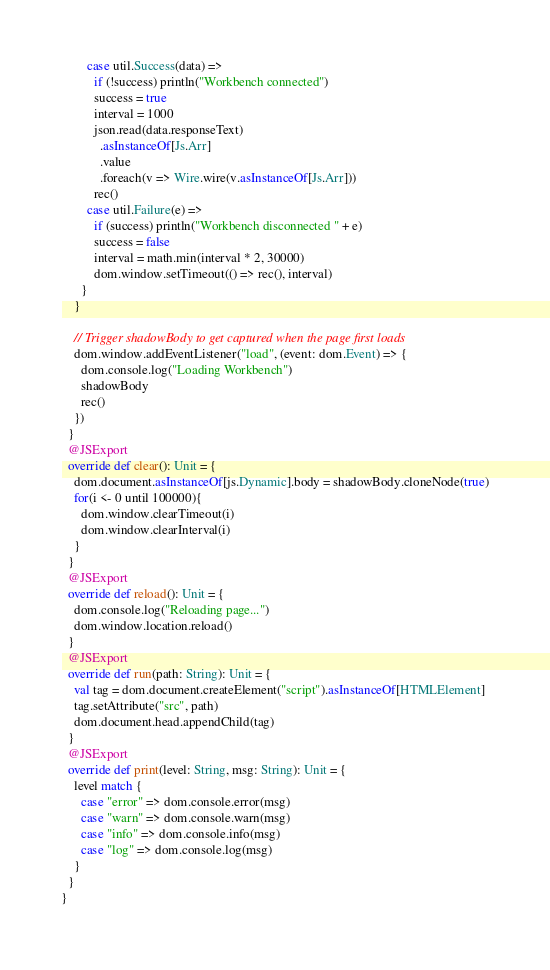<code> <loc_0><loc_0><loc_500><loc_500><_Scala_>        case util.Success(data) =>
          if (!success) println("Workbench connected")
          success = true
          interval = 1000
          json.read(data.responseText)
            .asInstanceOf[Js.Arr]
            .value
            .foreach(v => Wire.wire(v.asInstanceOf[Js.Arr]))
          rec()
        case util.Failure(e) =>
          if (success) println("Workbench disconnected " + e)
          success = false
          interval = math.min(interval * 2, 30000)
          dom.window.setTimeout(() => rec(), interval)
      }
    }

    // Trigger shadowBody to get captured when the page first loads
    dom.window.addEventListener("load", (event: dom.Event) => {
      dom.console.log("Loading Workbench")
      shadowBody
      rec()
    })
  }
  @JSExport
  override def clear(): Unit = {
    dom.document.asInstanceOf[js.Dynamic].body = shadowBody.cloneNode(true)
    for(i <- 0 until 100000){
      dom.window.clearTimeout(i)
      dom.window.clearInterval(i)
    }
  }
  @JSExport
  override def reload(): Unit = {
    dom.console.log("Reloading page...")
    dom.window.location.reload()
  }
  @JSExport
  override def run(path: String): Unit = {
    val tag = dom.document.createElement("script").asInstanceOf[HTMLElement]
    tag.setAttribute("src", path)
    dom.document.head.appendChild(tag)
  }
  @JSExport
  override def print(level: String, msg: String): Unit = {
    level match {
      case "error" => dom.console.error(msg)
      case "warn" => dom.console.warn(msg)
      case "info" => dom.console.info(msg)
      case "log" => dom.console.log(msg)
    }
  }
}
</code> 